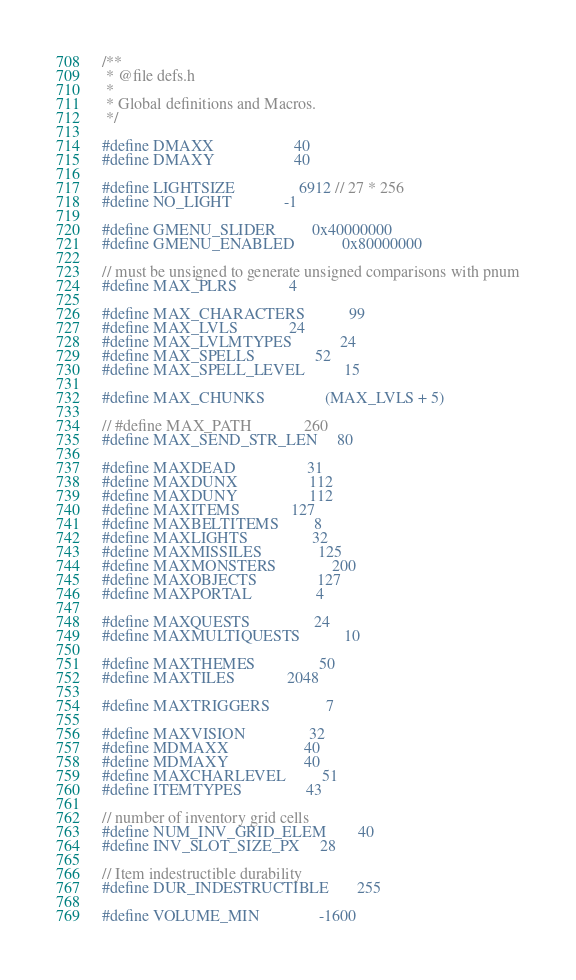Convert code to text. <code><loc_0><loc_0><loc_500><loc_500><_C_>/**
 * @file defs.h
 *
 * Global definitions and Macros.
 */

#define DMAXX					40
#define DMAXY					40

#define LIGHTSIZE				6912 // 27 * 256
#define NO_LIGHT				-1

#define GMENU_SLIDER			0x40000000
#define GMENU_ENABLED			0x80000000

// must be unsigned to generate unsigned comparisons with pnum
#define MAX_PLRS				4

#define MAX_CHARACTERS			99
#define MAX_LVLS				24
#define MAX_LVLMTYPES			24
#define MAX_SPELLS				52
#define MAX_SPELL_LEVEL			15

#define MAX_CHUNKS				(MAX_LVLS + 5)

// #define MAX_PATH				260
#define MAX_SEND_STR_LEN		80

#define MAXDEAD					31
#define MAXDUNX					112
#define MAXDUNY					112
#define MAXITEMS				127
#define MAXBELTITEMS			8
#define MAXLIGHTS				32
#define MAXMISSILES				125
#define MAXMONSTERS				200
#define MAXOBJECTS				127
#define MAXPORTAL				4

#define MAXQUESTS				24
#define MAXMULTIQUESTS			10

#define MAXTHEMES				50
#define MAXTILES				2048

#define MAXTRIGGERS				7

#define MAXVISION				32
#define MDMAXX					40
#define MDMAXY					40
#define MAXCHARLEVEL			51
#define ITEMTYPES				43

// number of inventory grid cells
#define NUM_INV_GRID_ELEM		40
#define INV_SLOT_SIZE_PX		28

// Item indestructible durability
#define DUR_INDESTRUCTIBLE		255

#define VOLUME_MIN				-1600</code> 